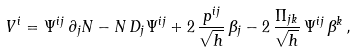<formula> <loc_0><loc_0><loc_500><loc_500>V ^ { i } = \Psi ^ { i j } \, \partial _ { j } N - N \, D _ { j } \Psi ^ { i j } + 2 \, \frac { p ^ { i j } } { \sqrt { h } } \, \beta _ { j } - 2 \, \frac { \Pi _ { j k } } { \sqrt { h } } \, \Psi ^ { i j } \, \beta ^ { k } \, ,</formula> 